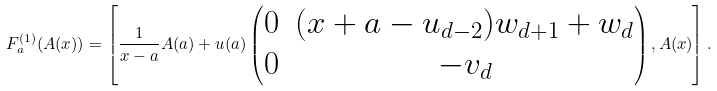<formula> <loc_0><loc_0><loc_500><loc_500>F _ { a } ^ { ( 1 ) } ( A ( x ) ) = \left [ \frac { 1 } { x - a } A ( a ) + u ( a ) \begin{pmatrix} 0 & ( x + a - u _ { d - 2 } ) w _ { d + 1 } + w _ { d } \\ 0 & - v _ { d } \end{pmatrix} , A ( x ) \right ] .</formula> 